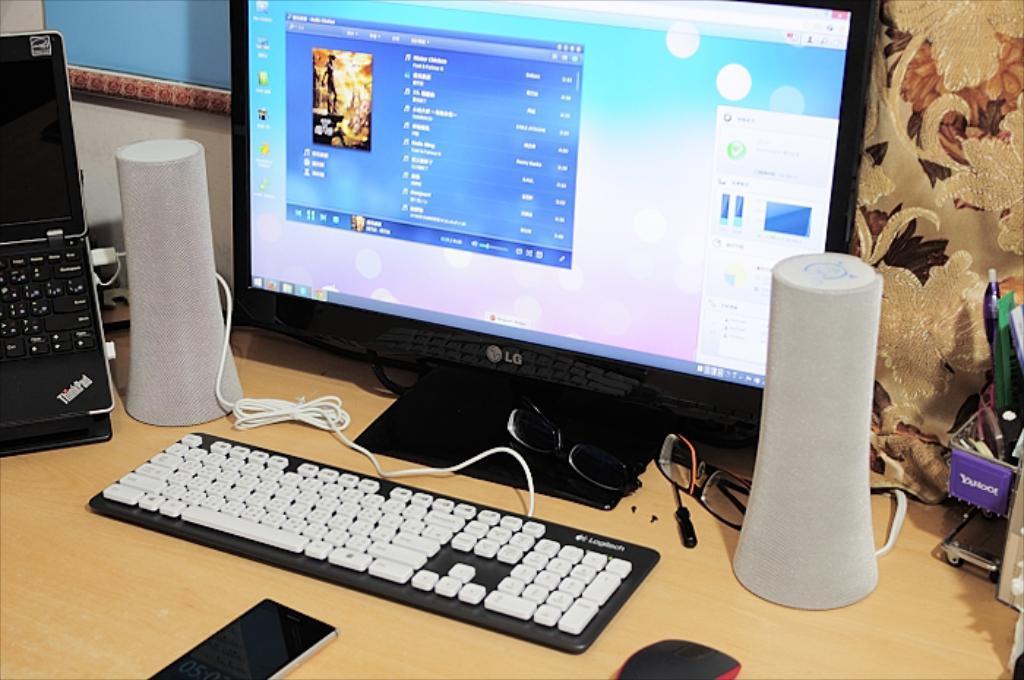Can you describe this image briefly? In the picture we can see a desk on it, we can see a monitor and a keyboard and besides it, we can see white color speakers with wires to it and beside it, we can see laptop which is black in color and a mobile phone near it and on the other side we can see a pen stand with some pens in it. 